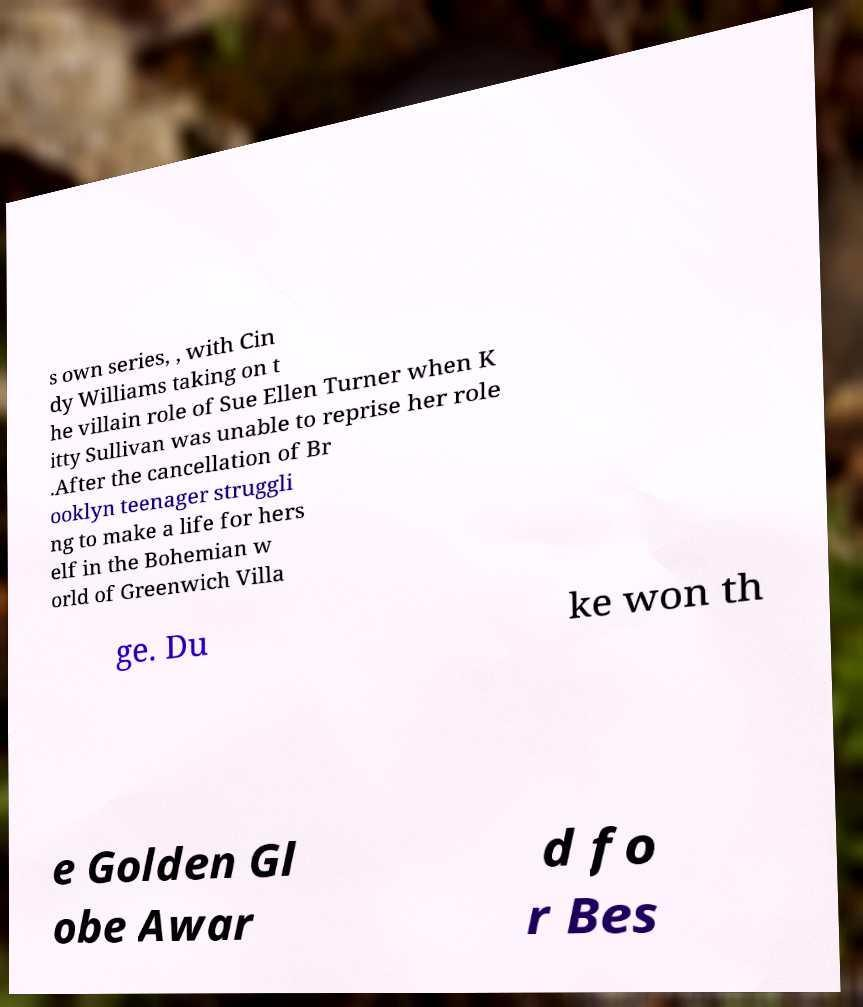I need the written content from this picture converted into text. Can you do that? s own series, , with Cin dy Williams taking on t he villain role of Sue Ellen Turner when K itty Sullivan was unable to reprise her role .After the cancellation of Br ooklyn teenager struggli ng to make a life for hers elf in the Bohemian w orld of Greenwich Villa ge. Du ke won th e Golden Gl obe Awar d fo r Bes 